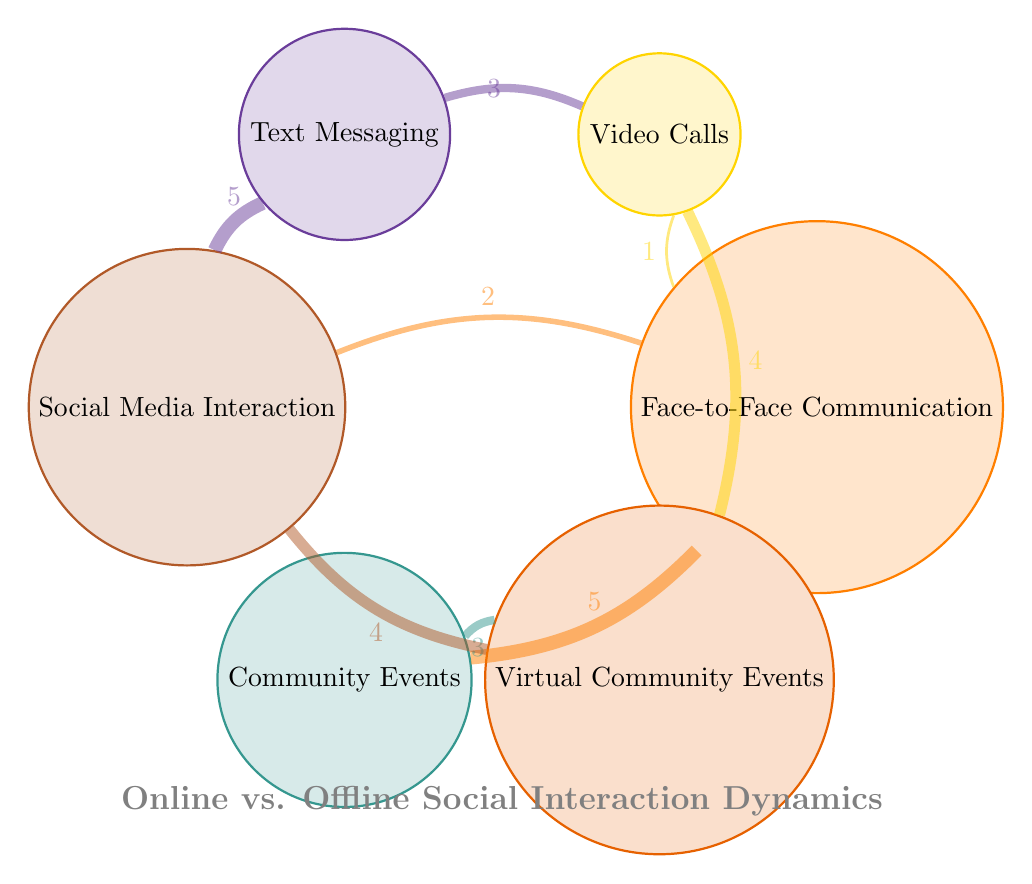What is the total number of nodes in the diagram? The diagram displays six nodes: Face-to-Face Communication, Video Calls, Text Messaging, Social Media Interaction, Community Events, and Virtual Community Events. Thus, counting them gives a total of six nodes.
Answer: 6 Which interaction has the highest connection value to Community Events? The connection with the highest value to Community Events is from Face-to-Face Communication, which has a value of 5.
Answer: 5 What is the value of the connection between Text Messaging and Social Media Interaction? The connection between Text Messaging and Social Media Interaction has a value of 5, as indicated in the diagram.
Answer: 5 How many connections does Video Calls have in total? Video Calls has two connections: it connects to Face-to-Face Communication with a value of 1 and to Virtual Community Events with a value of 4. Adding these gives a total connection value of 5.
Answer: 5 Which node does Text Messaging connect to with a value of 3? Text Messaging connects to Video Calls with a value of 3, as shown in the diagram.
Answer: Video Calls What is the relationship between Social Media Interaction and Virtual Community Events? The relationship between Social Media Interaction and Virtual Community Events has a value of 4, indicating a significant connection between the two.
Answer: 4 Which offline interaction has a lower connection value to Online interactions? Face-to-Face Communication has a lower connection value of 2 to Social Media Interaction compared to other connections in the diagram.
Answer: 2 Which interaction connects Face-to-Face Communication and Virtual Community Events, and what is its value? The interaction connecting Face-to-Face Communication and Virtual Community Events is through Community Events, which has a connection value of 3 to Virtual Community Events.
Answer: 3 Which type of interaction is part of both online and offline interactions? Text Messaging is part of both online interactions (such as Social Media Interaction) and offline interactions (such as Video Calls).
Answer: Text Messaging 